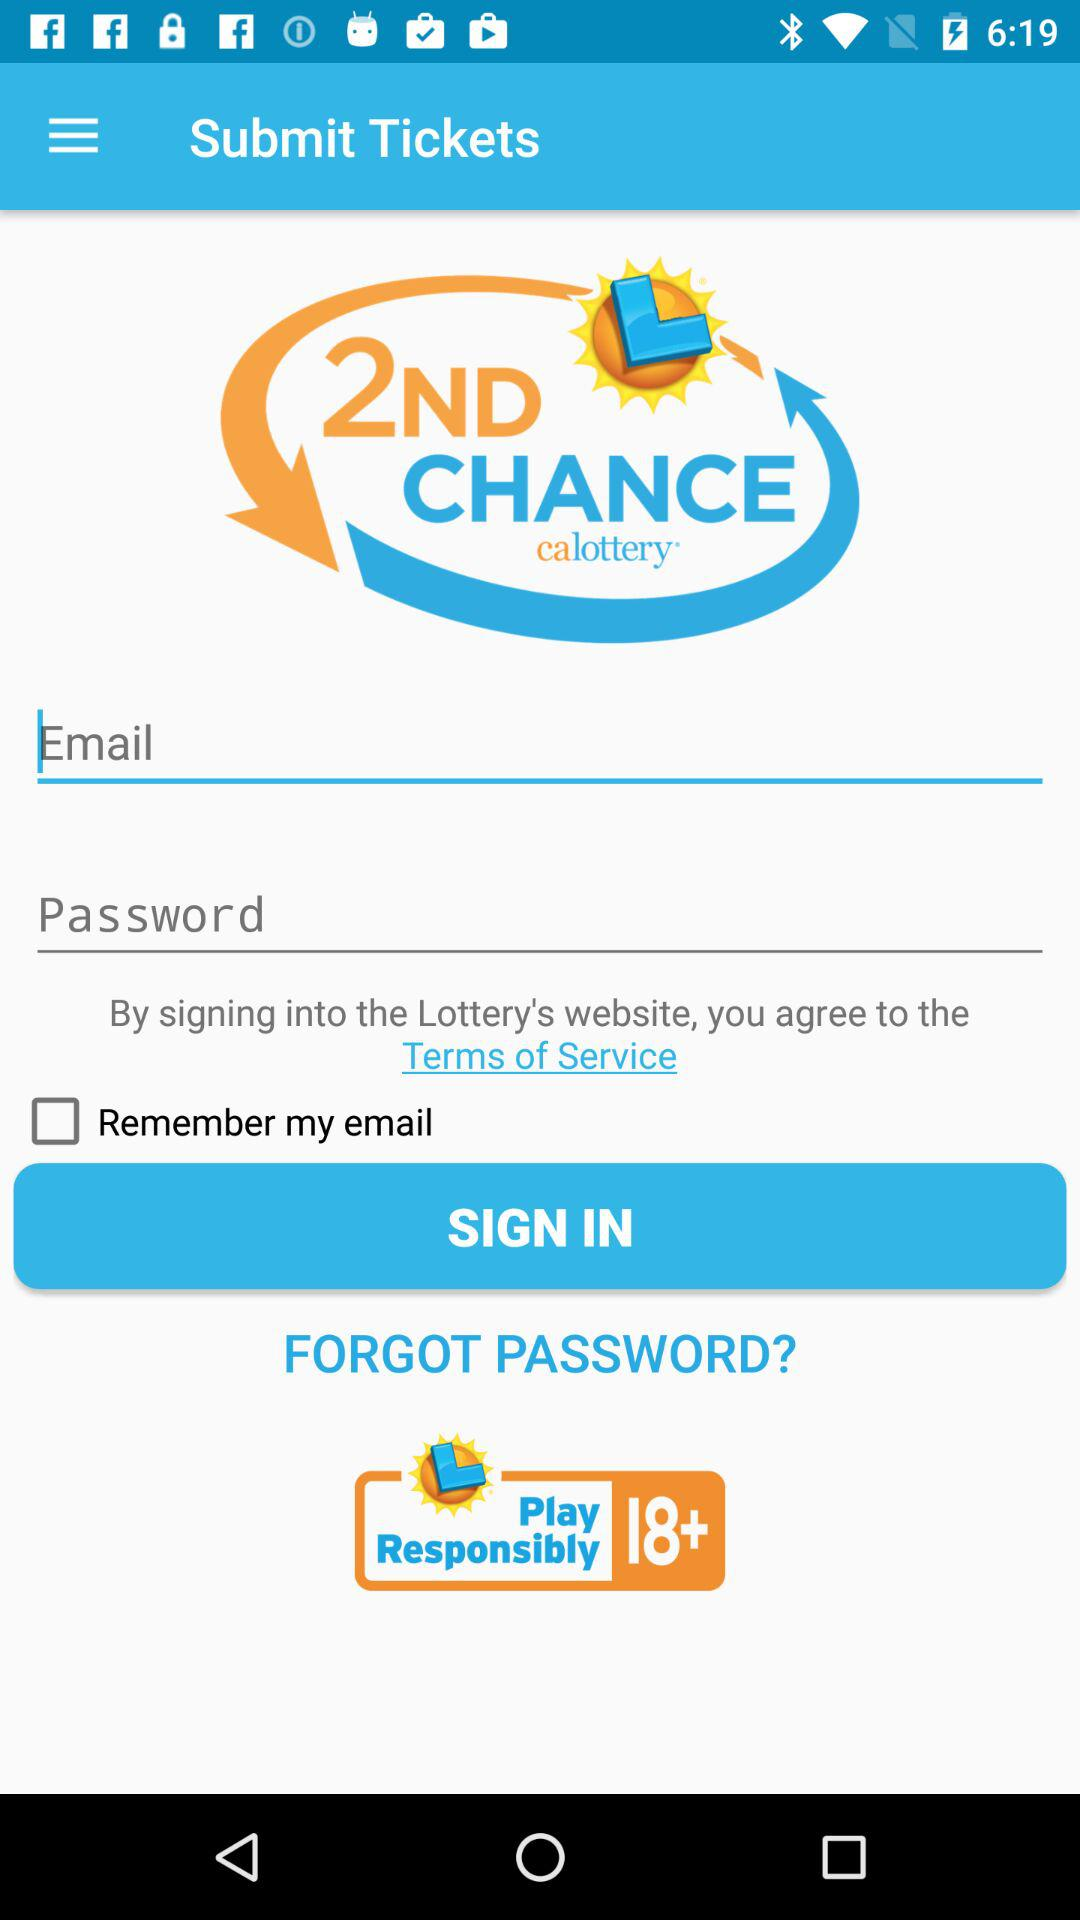What is the name of the application? The name of the application is "calottery". 